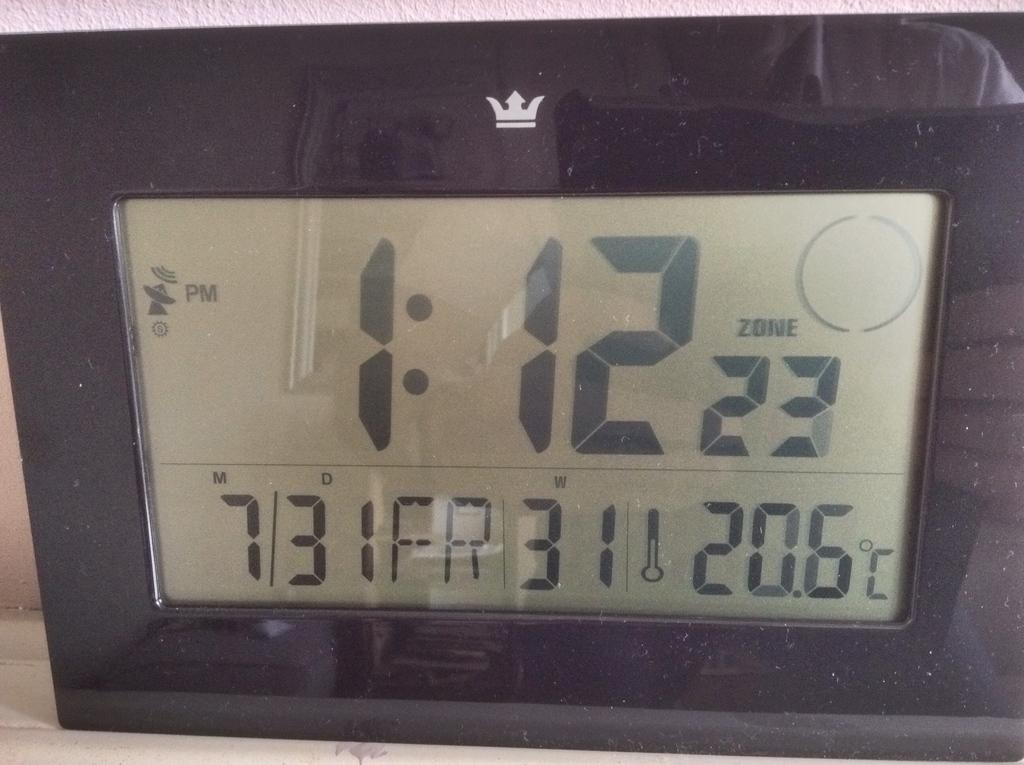What type of electronic device is present in the image? There is an electronic device in the image, but the specific type cannot be determined from the provided facts. What can be seen on the electronic device? There are numbers visible on the electronic device. How many pickles are on the yard in the image? There is no yard or pickles present in the image. 